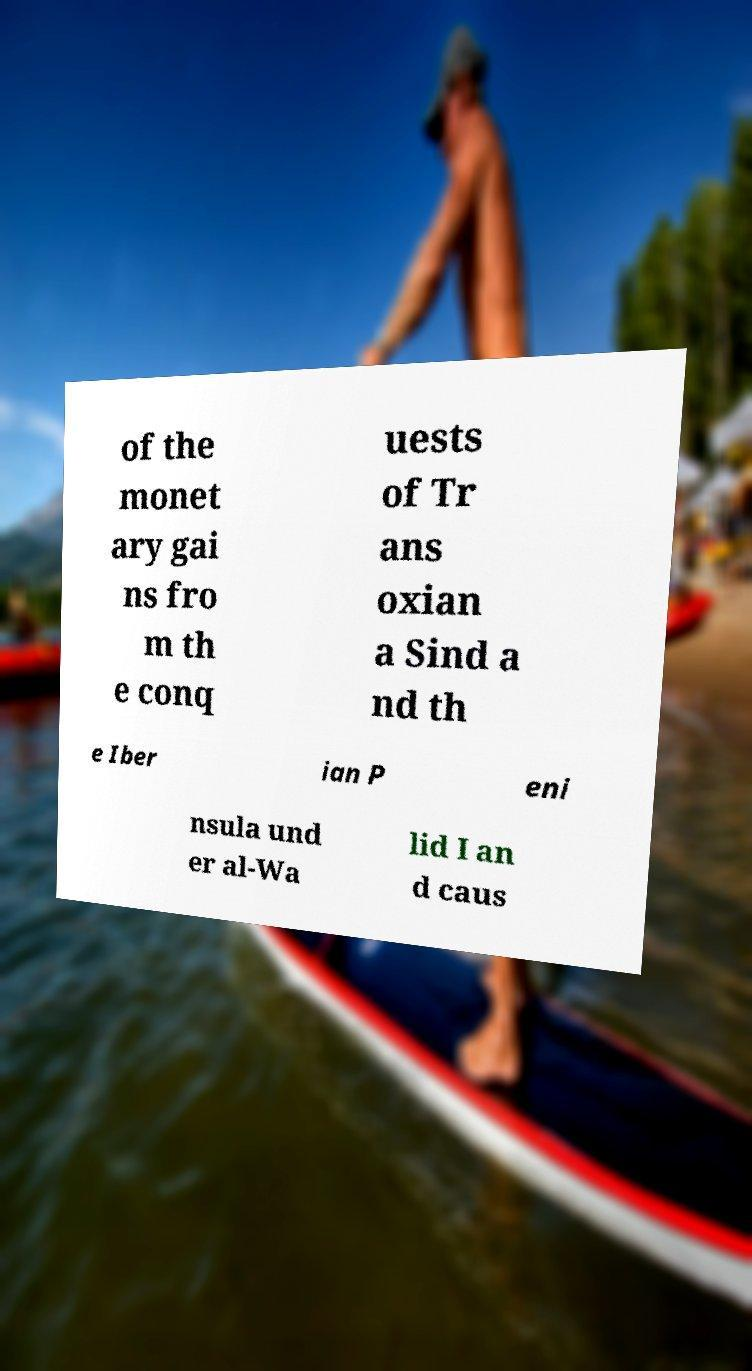There's text embedded in this image that I need extracted. Can you transcribe it verbatim? of the monet ary gai ns fro m th e conq uests of Tr ans oxian a Sind a nd th e Iber ian P eni nsula und er al-Wa lid I an d caus 